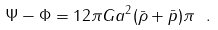<formula> <loc_0><loc_0><loc_500><loc_500>\Psi - \Phi = 1 2 \pi G a ^ { 2 } ( \bar { \rho } + \bar { p } ) \pi \ .</formula> 